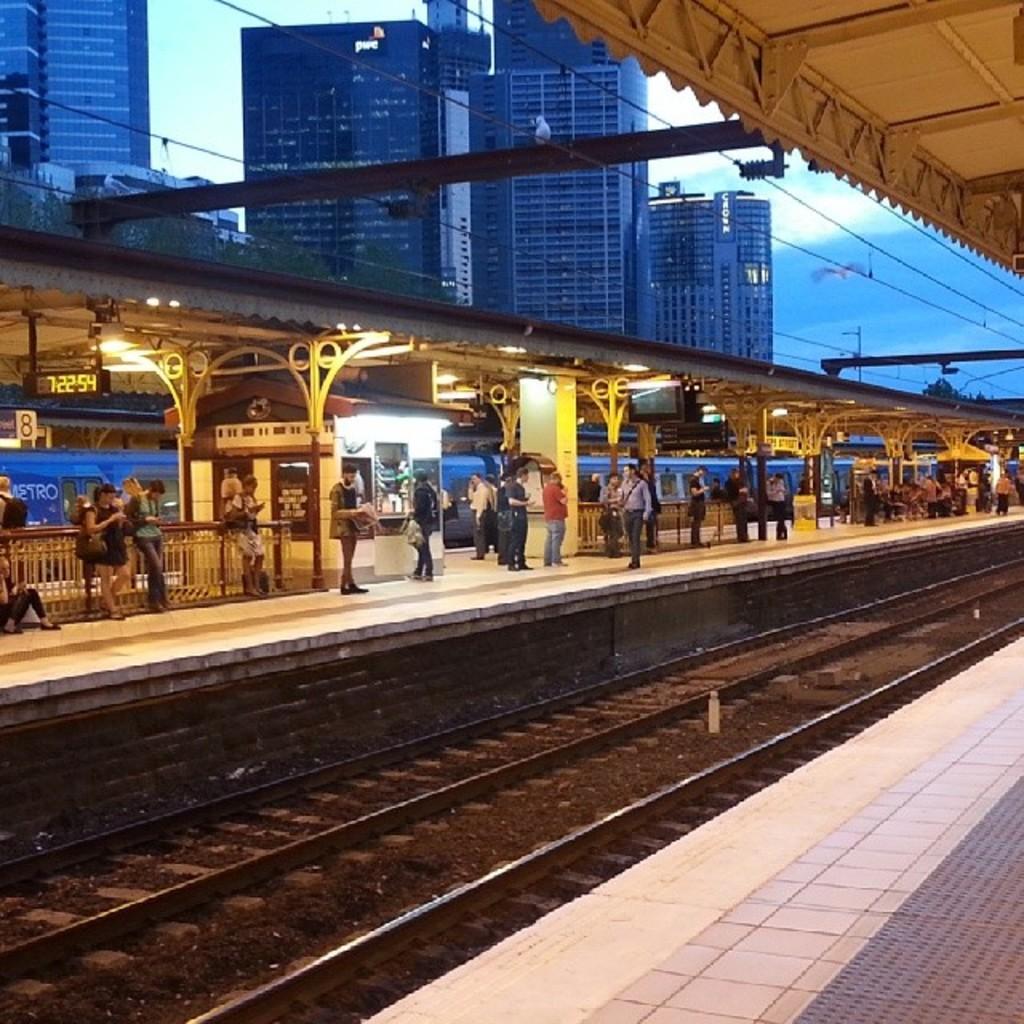Could you give a brief overview of what you see in this image? This picture describes about group of people, few are seated and few are standing, in this we can find few tracks, buildings, cables and lights. 